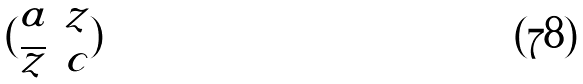<formula> <loc_0><loc_0><loc_500><loc_500>( \begin{matrix} a & z \\ \overline { z } & c \end{matrix} )</formula> 